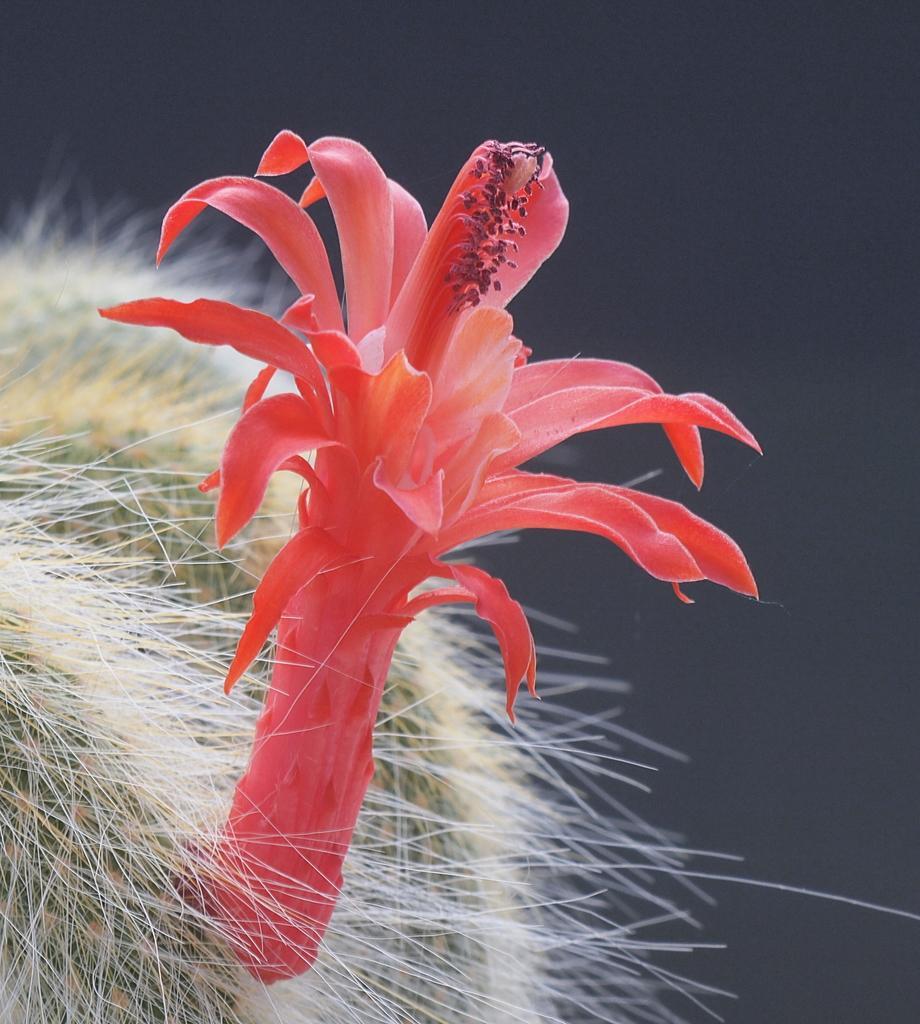In one or two sentences, can you explain what this image depicts? This is the picture of a flower which is to the cactus plant. 